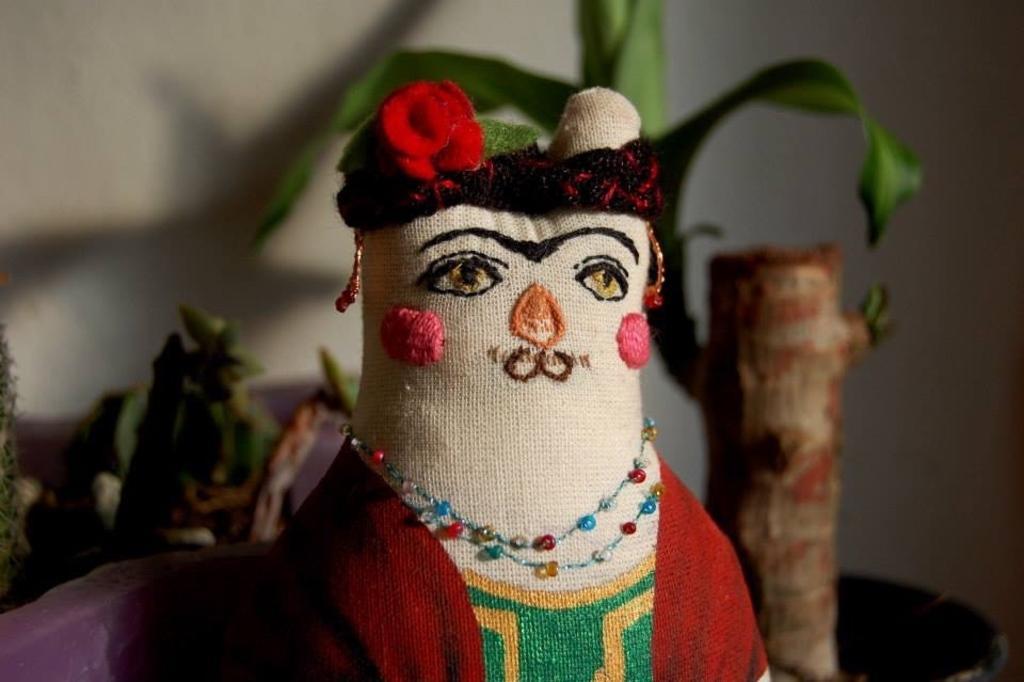In one or two sentences, can you explain what this image depicts? In the picture I can see a toy. In the background I can see planets and a wall. 